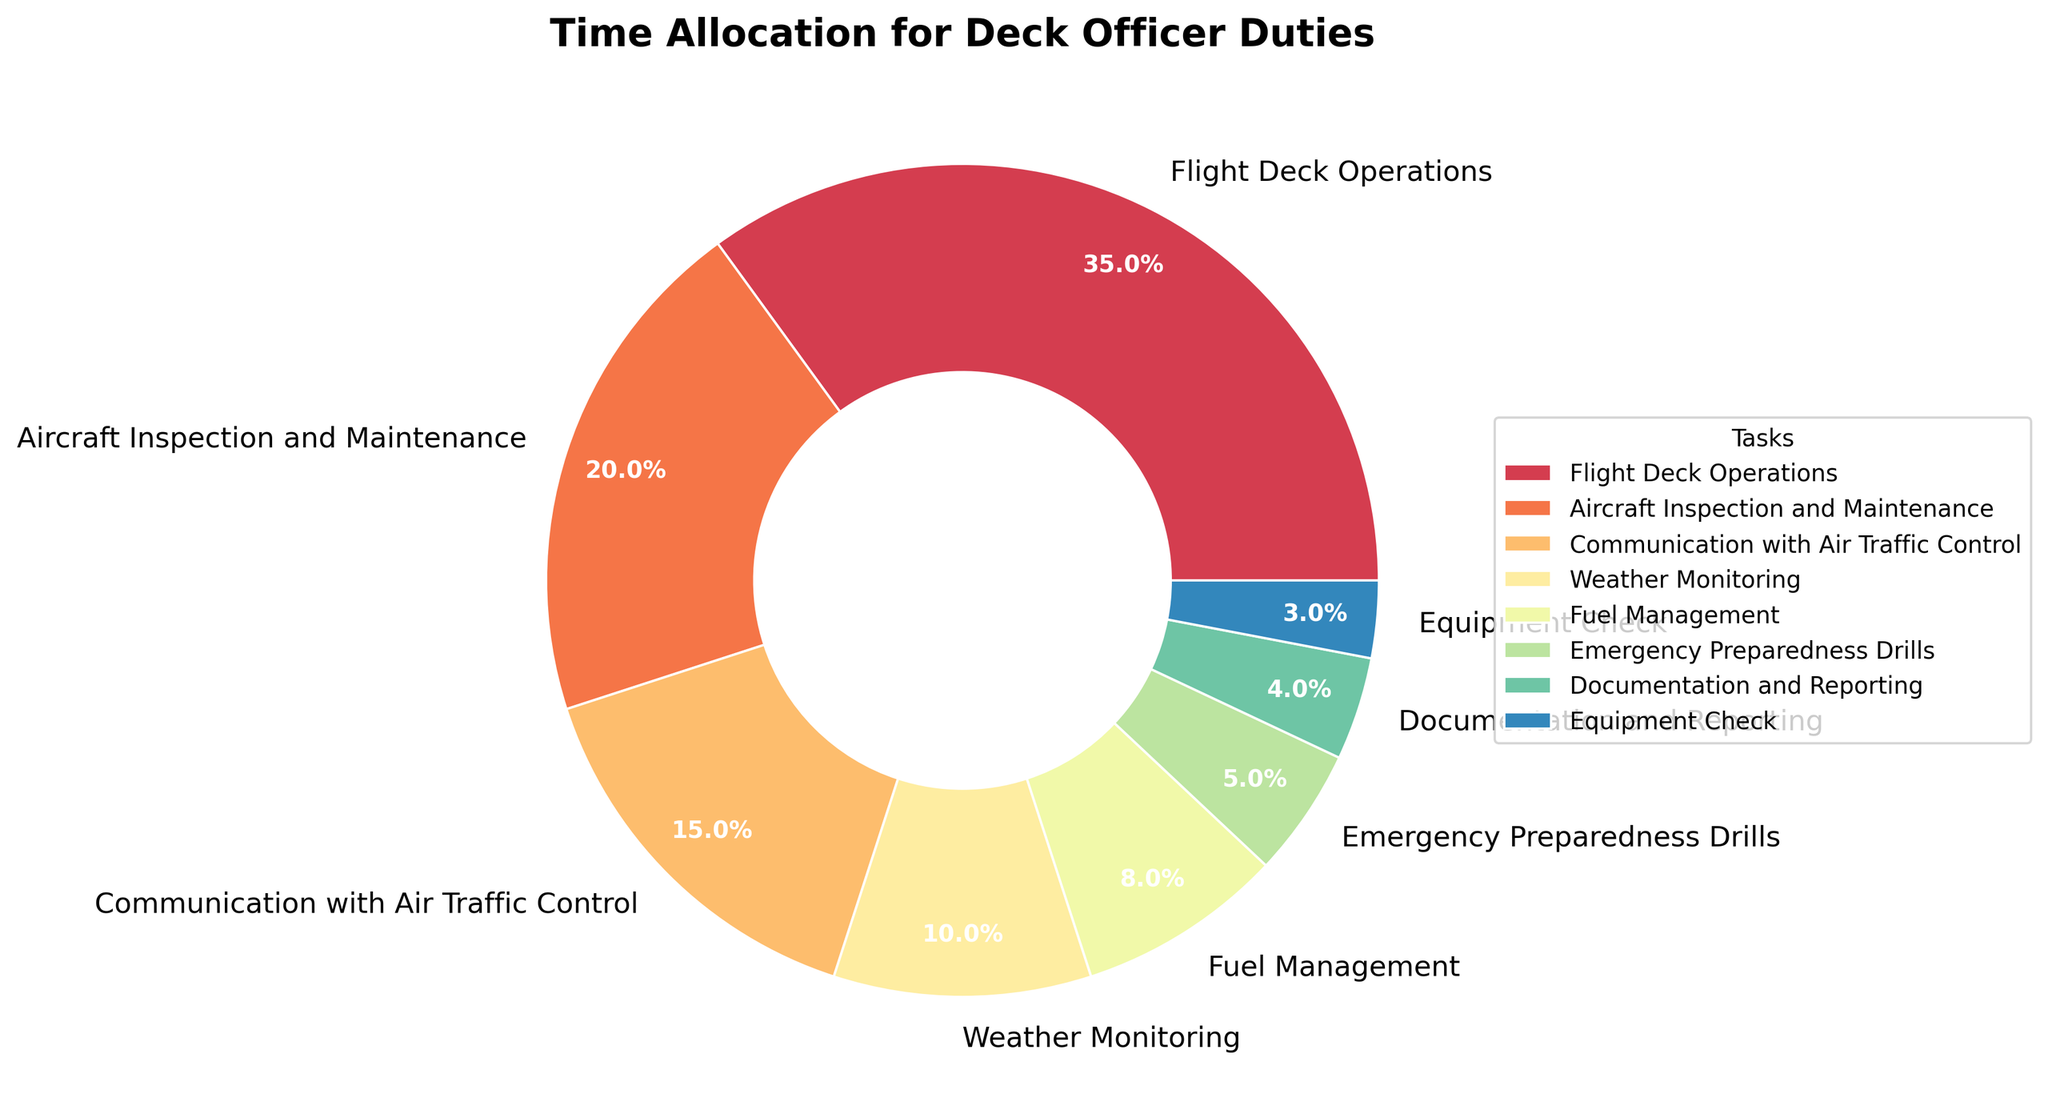What task allocates the highest percentage of time? Looking at the chart, "Flight Deck Operations" takes up the largest portion of the pie, which is 35%.
Answer: Flight Deck Operations Which two activities together take up 15% of the time? Observing the chart, "Emergency Preparedness Drills" (5%) and "Documentation and Reporting" (4%) together make 9%, but adding "Equipment Check" (3%) with those two tasks does not add up to 15%. However, "Communication with Air Traffic Control" alone is 15%. Therefore, none of the smaller tasks combined fit exactly 15%.
Answer: Communication with Air Traffic Control Compare the time spent on "Aircraft Inspection and Maintenance" to "Weather Monitoring" and state which one has more time allocated. Checking the pie chart, "Aircraft Inspection and Maintenance" has a slice of 20%, whereas "Weather Monitoring" holds 10%. Thus, "Aircraft Inspection and Maintenance" has more time allocated.
Answer: Aircraft Inspection and Maintenance What is the combined percentage of time allocated to "Emergency Preparedness Drills", "Documentation and Reporting", and "Equipment Check"? Adding the percentages from the chart: 5% for "Emergency Preparedness Drills", 4% for "Documentation and Reporting", and 3% for "Equipment Check" yields 5 + 4 + 3 = 12%.
Answer: 12% By how much does the time spent on "Fuel Management" exceed the time spent on "Equipment Check"? The chart shows "Fuel Management" at 8% and "Equipment Check" at 3%, so the difference is 8% - 3% = 5%.
Answer: 5% What is the visual color representing the "Fuel Management" task? Observing the chart, "Fuel Management" is represented by a specific color which needs to be referenced directly from the pie chart's visual guide.
Answer: Color of "Fuel Management" Which tasks together take up over half of the total time allocation? The tasks are "Flight Deck Operations" (35%), "Aircraft Inspection and Maintenance" (20%), and the sum of these alone is 55%, which is more than half.
Answer: Flight Deck Operations, Aircraft Inspection and Maintenance 